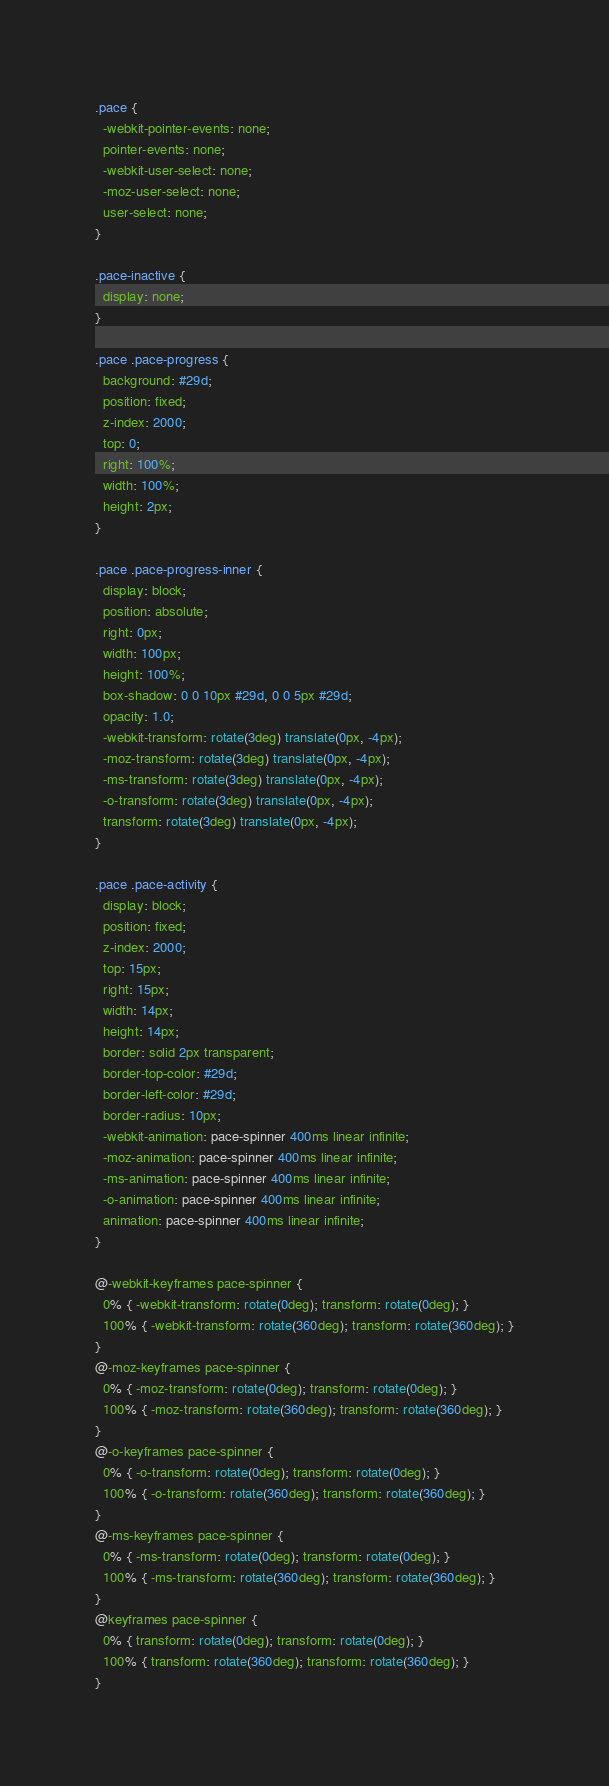Convert code to text. <code><loc_0><loc_0><loc_500><loc_500><_CSS_>.pace {
  -webkit-pointer-events: none;
  pointer-events: none;
  -webkit-user-select: none;
  -moz-user-select: none;
  user-select: none;
}

.pace-inactive {
  display: none;
}

.pace .pace-progress {
  background: #29d;
  position: fixed;
  z-index: 2000;
  top: 0;
  right: 100%;
  width: 100%;
  height: 2px;
}

.pace .pace-progress-inner {
  display: block;
  position: absolute;
  right: 0px;
  width: 100px;
  height: 100%;
  box-shadow: 0 0 10px #29d, 0 0 5px #29d;
  opacity: 1.0;
  -webkit-transform: rotate(3deg) translate(0px, -4px);
  -moz-transform: rotate(3deg) translate(0px, -4px);
  -ms-transform: rotate(3deg) translate(0px, -4px);
  -o-transform: rotate(3deg) translate(0px, -4px);
  transform: rotate(3deg) translate(0px, -4px);
}

.pace .pace-activity {
  display: block;
  position: fixed;
  z-index: 2000;
  top: 15px;
  right: 15px;
  width: 14px;
  height: 14px;
  border: solid 2px transparent;
  border-top-color: #29d;
  border-left-color: #29d;
  border-radius: 10px;
  -webkit-animation: pace-spinner 400ms linear infinite;
  -moz-animation: pace-spinner 400ms linear infinite;
  -ms-animation: pace-spinner 400ms linear infinite;
  -o-animation: pace-spinner 400ms linear infinite;
  animation: pace-spinner 400ms linear infinite;
}

@-webkit-keyframes pace-spinner {
  0% { -webkit-transform: rotate(0deg); transform: rotate(0deg); }
  100% { -webkit-transform: rotate(360deg); transform: rotate(360deg); }
}
@-moz-keyframes pace-spinner {
  0% { -moz-transform: rotate(0deg); transform: rotate(0deg); }
  100% { -moz-transform: rotate(360deg); transform: rotate(360deg); }
}
@-o-keyframes pace-spinner {
  0% { -o-transform: rotate(0deg); transform: rotate(0deg); }
  100% { -o-transform: rotate(360deg); transform: rotate(360deg); }
}
@-ms-keyframes pace-spinner {
  0% { -ms-transform: rotate(0deg); transform: rotate(0deg); }
  100% { -ms-transform: rotate(360deg); transform: rotate(360deg); }
}
@keyframes pace-spinner {
  0% { transform: rotate(0deg); transform: rotate(0deg); }
  100% { transform: rotate(360deg); transform: rotate(360deg); }
}

</code> 